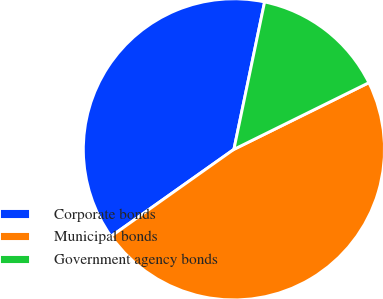Convert chart. <chart><loc_0><loc_0><loc_500><loc_500><pie_chart><fcel>Corporate bonds<fcel>Municipal bonds<fcel>Government agency bonds<nl><fcel>38.07%<fcel>47.5%<fcel>14.43%<nl></chart> 